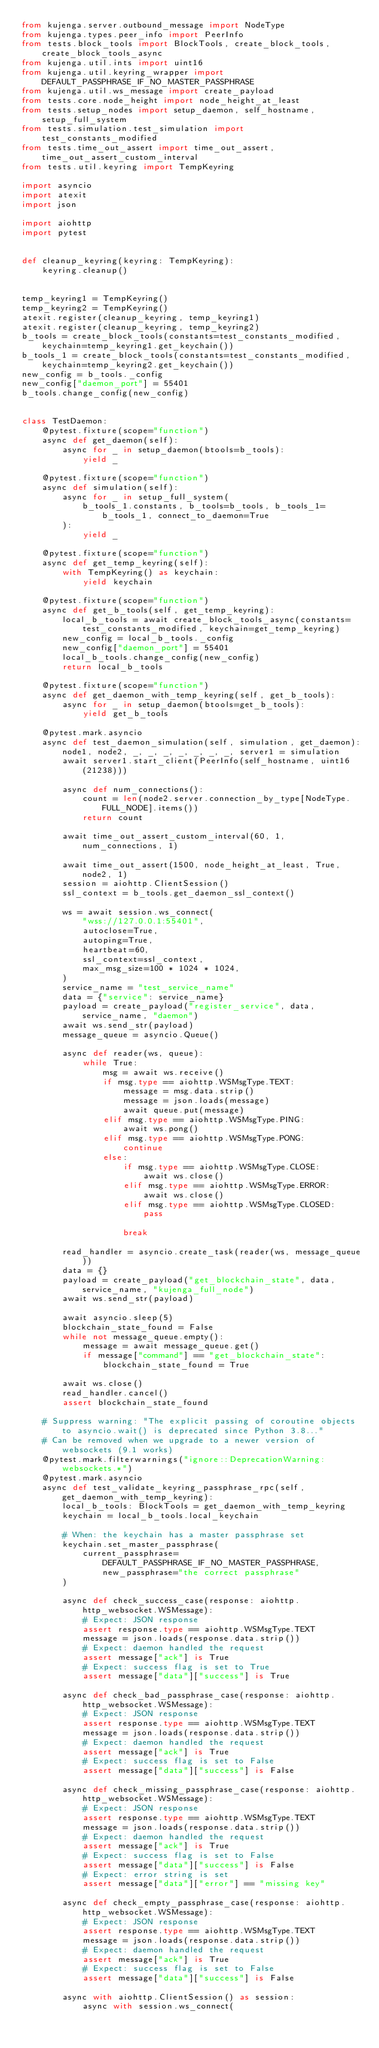<code> <loc_0><loc_0><loc_500><loc_500><_Python_>from kujenga.server.outbound_message import NodeType
from kujenga.types.peer_info import PeerInfo
from tests.block_tools import BlockTools, create_block_tools, create_block_tools_async
from kujenga.util.ints import uint16
from kujenga.util.keyring_wrapper import DEFAULT_PASSPHRASE_IF_NO_MASTER_PASSPHRASE
from kujenga.util.ws_message import create_payload
from tests.core.node_height import node_height_at_least
from tests.setup_nodes import setup_daemon, self_hostname, setup_full_system
from tests.simulation.test_simulation import test_constants_modified
from tests.time_out_assert import time_out_assert, time_out_assert_custom_interval
from tests.util.keyring import TempKeyring

import asyncio
import atexit
import json

import aiohttp
import pytest


def cleanup_keyring(keyring: TempKeyring):
    keyring.cleanup()


temp_keyring1 = TempKeyring()
temp_keyring2 = TempKeyring()
atexit.register(cleanup_keyring, temp_keyring1)
atexit.register(cleanup_keyring, temp_keyring2)
b_tools = create_block_tools(constants=test_constants_modified, keychain=temp_keyring1.get_keychain())
b_tools_1 = create_block_tools(constants=test_constants_modified, keychain=temp_keyring2.get_keychain())
new_config = b_tools._config
new_config["daemon_port"] = 55401
b_tools.change_config(new_config)


class TestDaemon:
    @pytest.fixture(scope="function")
    async def get_daemon(self):
        async for _ in setup_daemon(btools=b_tools):
            yield _

    @pytest.fixture(scope="function")
    async def simulation(self):
        async for _ in setup_full_system(
            b_tools_1.constants, b_tools=b_tools, b_tools_1=b_tools_1, connect_to_daemon=True
        ):
            yield _

    @pytest.fixture(scope="function")
    async def get_temp_keyring(self):
        with TempKeyring() as keychain:
            yield keychain

    @pytest.fixture(scope="function")
    async def get_b_tools(self, get_temp_keyring):
        local_b_tools = await create_block_tools_async(constants=test_constants_modified, keychain=get_temp_keyring)
        new_config = local_b_tools._config
        new_config["daemon_port"] = 55401
        local_b_tools.change_config(new_config)
        return local_b_tools

    @pytest.fixture(scope="function")
    async def get_daemon_with_temp_keyring(self, get_b_tools):
        async for _ in setup_daemon(btools=get_b_tools):
            yield get_b_tools

    @pytest.mark.asyncio
    async def test_daemon_simulation(self, simulation, get_daemon):
        node1, node2, _, _, _, _, _, _, _, server1 = simulation
        await server1.start_client(PeerInfo(self_hostname, uint16(21238)))

        async def num_connections():
            count = len(node2.server.connection_by_type[NodeType.FULL_NODE].items())
            return count

        await time_out_assert_custom_interval(60, 1, num_connections, 1)

        await time_out_assert(1500, node_height_at_least, True, node2, 1)
        session = aiohttp.ClientSession()
        ssl_context = b_tools.get_daemon_ssl_context()

        ws = await session.ws_connect(
            "wss://127.0.0.1:55401",
            autoclose=True,
            autoping=True,
            heartbeat=60,
            ssl_context=ssl_context,
            max_msg_size=100 * 1024 * 1024,
        )
        service_name = "test_service_name"
        data = {"service": service_name}
        payload = create_payload("register_service", data, service_name, "daemon")
        await ws.send_str(payload)
        message_queue = asyncio.Queue()

        async def reader(ws, queue):
            while True:
                msg = await ws.receive()
                if msg.type == aiohttp.WSMsgType.TEXT:
                    message = msg.data.strip()
                    message = json.loads(message)
                    await queue.put(message)
                elif msg.type == aiohttp.WSMsgType.PING:
                    await ws.pong()
                elif msg.type == aiohttp.WSMsgType.PONG:
                    continue
                else:
                    if msg.type == aiohttp.WSMsgType.CLOSE:
                        await ws.close()
                    elif msg.type == aiohttp.WSMsgType.ERROR:
                        await ws.close()
                    elif msg.type == aiohttp.WSMsgType.CLOSED:
                        pass

                    break

        read_handler = asyncio.create_task(reader(ws, message_queue))
        data = {}
        payload = create_payload("get_blockchain_state", data, service_name, "kujenga_full_node")
        await ws.send_str(payload)

        await asyncio.sleep(5)
        blockchain_state_found = False
        while not message_queue.empty():
            message = await message_queue.get()
            if message["command"] == "get_blockchain_state":
                blockchain_state_found = True

        await ws.close()
        read_handler.cancel()
        assert blockchain_state_found

    # Suppress warning: "The explicit passing of coroutine objects to asyncio.wait() is deprecated since Python 3.8..."
    # Can be removed when we upgrade to a newer version of websockets (9.1 works)
    @pytest.mark.filterwarnings("ignore::DeprecationWarning:websockets.*")
    @pytest.mark.asyncio
    async def test_validate_keyring_passphrase_rpc(self, get_daemon_with_temp_keyring):
        local_b_tools: BlockTools = get_daemon_with_temp_keyring
        keychain = local_b_tools.local_keychain

        # When: the keychain has a master passphrase set
        keychain.set_master_passphrase(
            current_passphrase=DEFAULT_PASSPHRASE_IF_NO_MASTER_PASSPHRASE, new_passphrase="the correct passphrase"
        )

        async def check_success_case(response: aiohttp.http_websocket.WSMessage):
            # Expect: JSON response
            assert response.type == aiohttp.WSMsgType.TEXT
            message = json.loads(response.data.strip())
            # Expect: daemon handled the request
            assert message["ack"] is True
            # Expect: success flag is set to True
            assert message["data"]["success"] is True

        async def check_bad_passphrase_case(response: aiohttp.http_websocket.WSMessage):
            # Expect: JSON response
            assert response.type == aiohttp.WSMsgType.TEXT
            message = json.loads(response.data.strip())
            # Expect: daemon handled the request
            assert message["ack"] is True
            # Expect: success flag is set to False
            assert message["data"]["success"] is False

        async def check_missing_passphrase_case(response: aiohttp.http_websocket.WSMessage):
            # Expect: JSON response
            assert response.type == aiohttp.WSMsgType.TEXT
            message = json.loads(response.data.strip())
            # Expect: daemon handled the request
            assert message["ack"] is True
            # Expect: success flag is set to False
            assert message["data"]["success"] is False
            # Expect: error string is set
            assert message["data"]["error"] == "missing key"

        async def check_empty_passphrase_case(response: aiohttp.http_websocket.WSMessage):
            # Expect: JSON response
            assert response.type == aiohttp.WSMsgType.TEXT
            message = json.loads(response.data.strip())
            # Expect: daemon handled the request
            assert message["ack"] is True
            # Expect: success flag is set to False
            assert message["data"]["success"] is False

        async with aiohttp.ClientSession() as session:
            async with session.ws_connect(</code> 